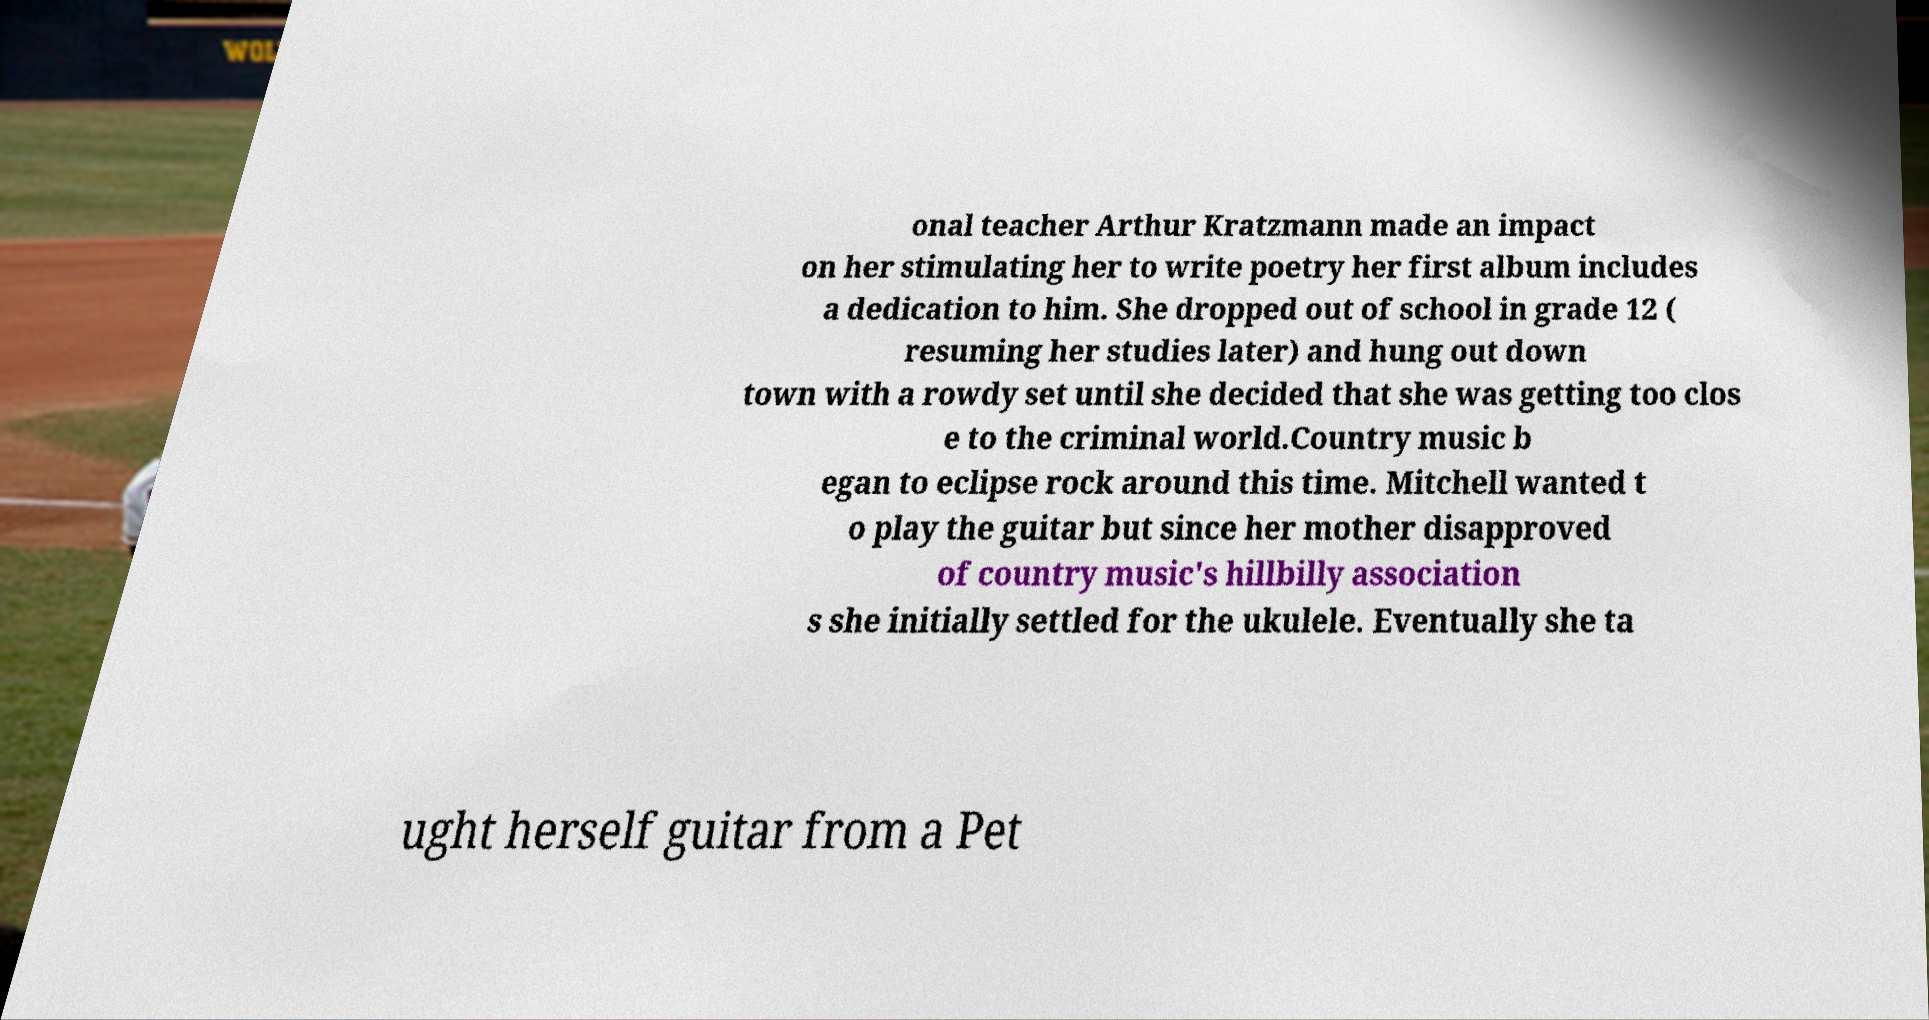I need the written content from this picture converted into text. Can you do that? onal teacher Arthur Kratzmann made an impact on her stimulating her to write poetry her first album includes a dedication to him. She dropped out of school in grade 12 ( resuming her studies later) and hung out down town with a rowdy set until she decided that she was getting too clos e to the criminal world.Country music b egan to eclipse rock around this time. Mitchell wanted t o play the guitar but since her mother disapproved of country music's hillbilly association s she initially settled for the ukulele. Eventually she ta ught herself guitar from a Pet 